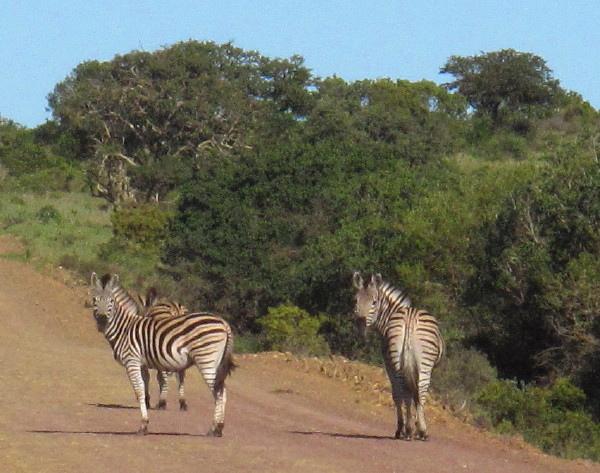Are the zebras walking on a road?
Write a very short answer. Yes. Where are the zebras?
Be succinct. Road. Are there any baby animals?
Write a very short answer. No. Is it raining?
Short answer required. No. How many horses are there?
Quick response, please. 0. 